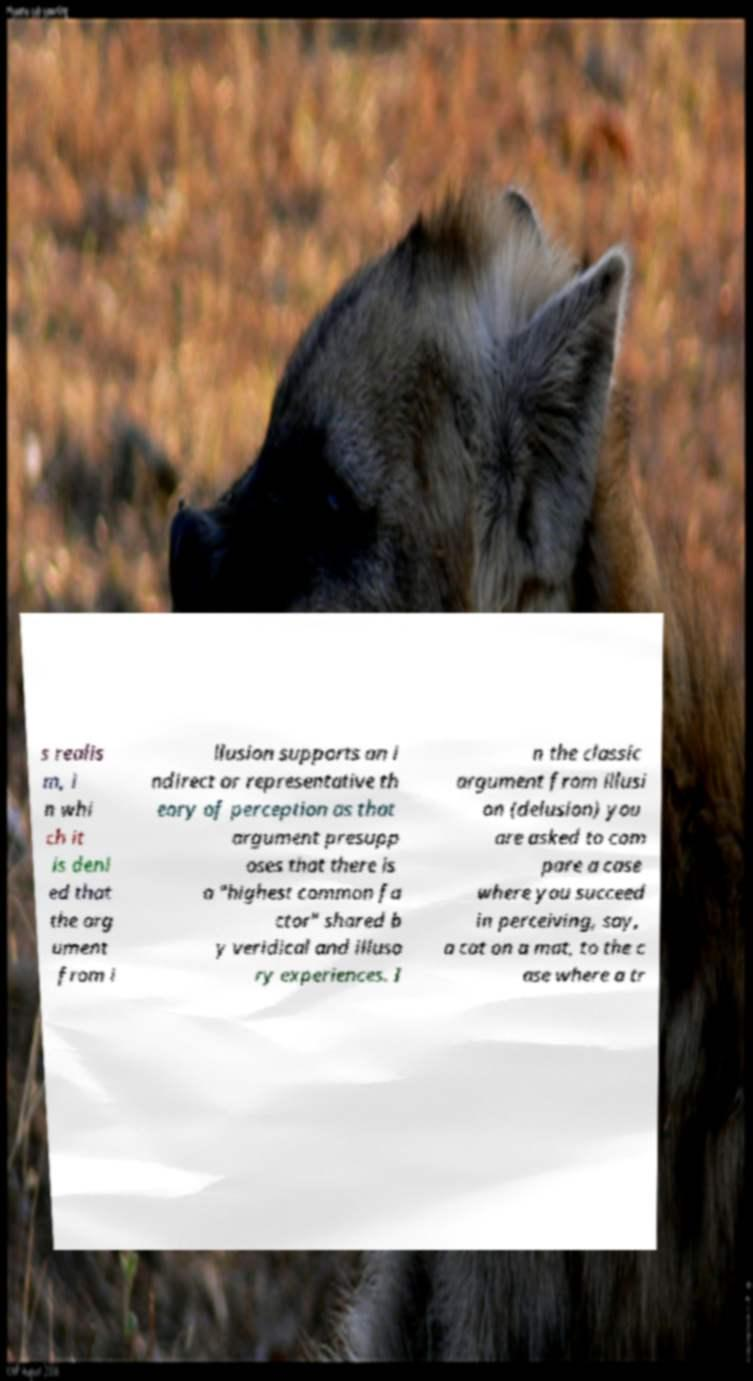Please identify and transcribe the text found in this image. s realis m, i n whi ch it is deni ed that the arg ument from i llusion supports an i ndirect or representative th eory of perception as that argument presupp oses that there is a "highest common fa ctor" shared b y veridical and illuso ry experiences. I n the classic argument from illusi on (delusion) you are asked to com pare a case where you succeed in perceiving, say, a cat on a mat, to the c ase where a tr 